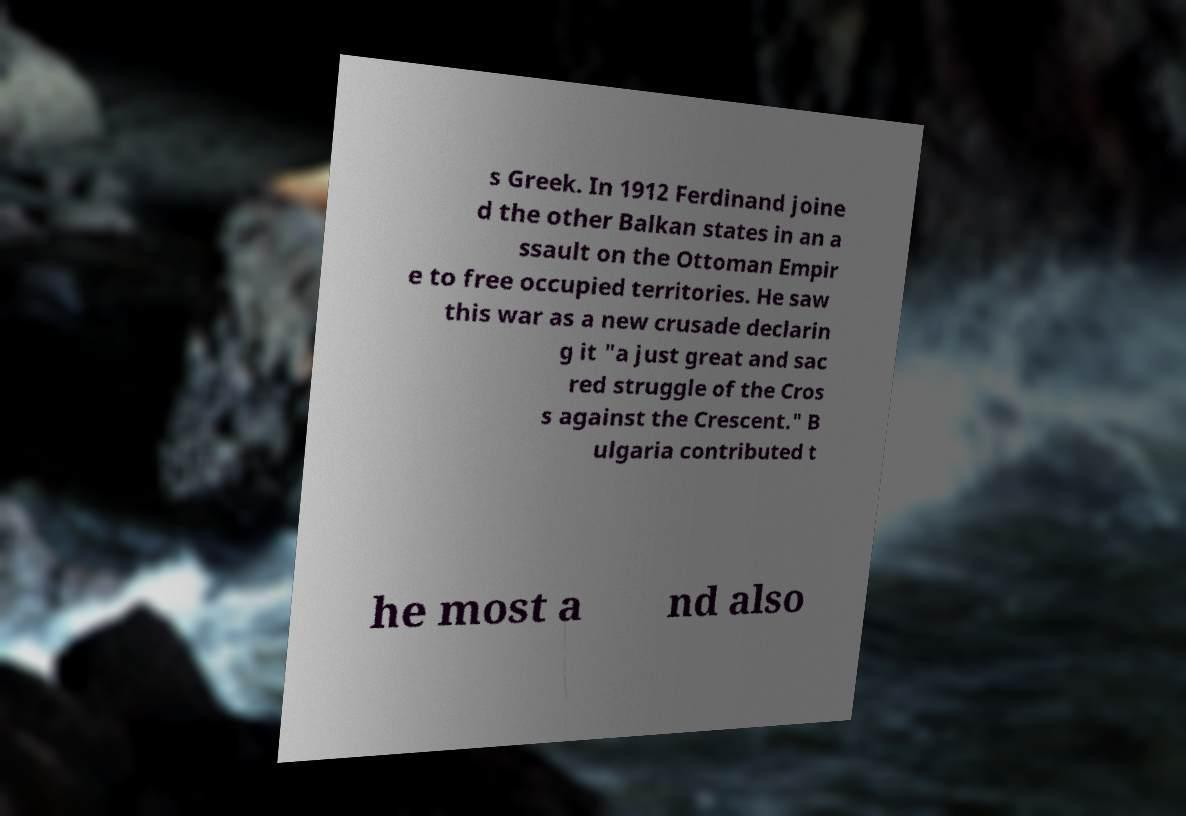Can you read and provide the text displayed in the image?This photo seems to have some interesting text. Can you extract and type it out for me? s Greek. In 1912 Ferdinand joine d the other Balkan states in an a ssault on the Ottoman Empir e to free occupied territories. He saw this war as a new crusade declarin g it "a just great and sac red struggle of the Cros s against the Crescent." B ulgaria contributed t he most a nd also 